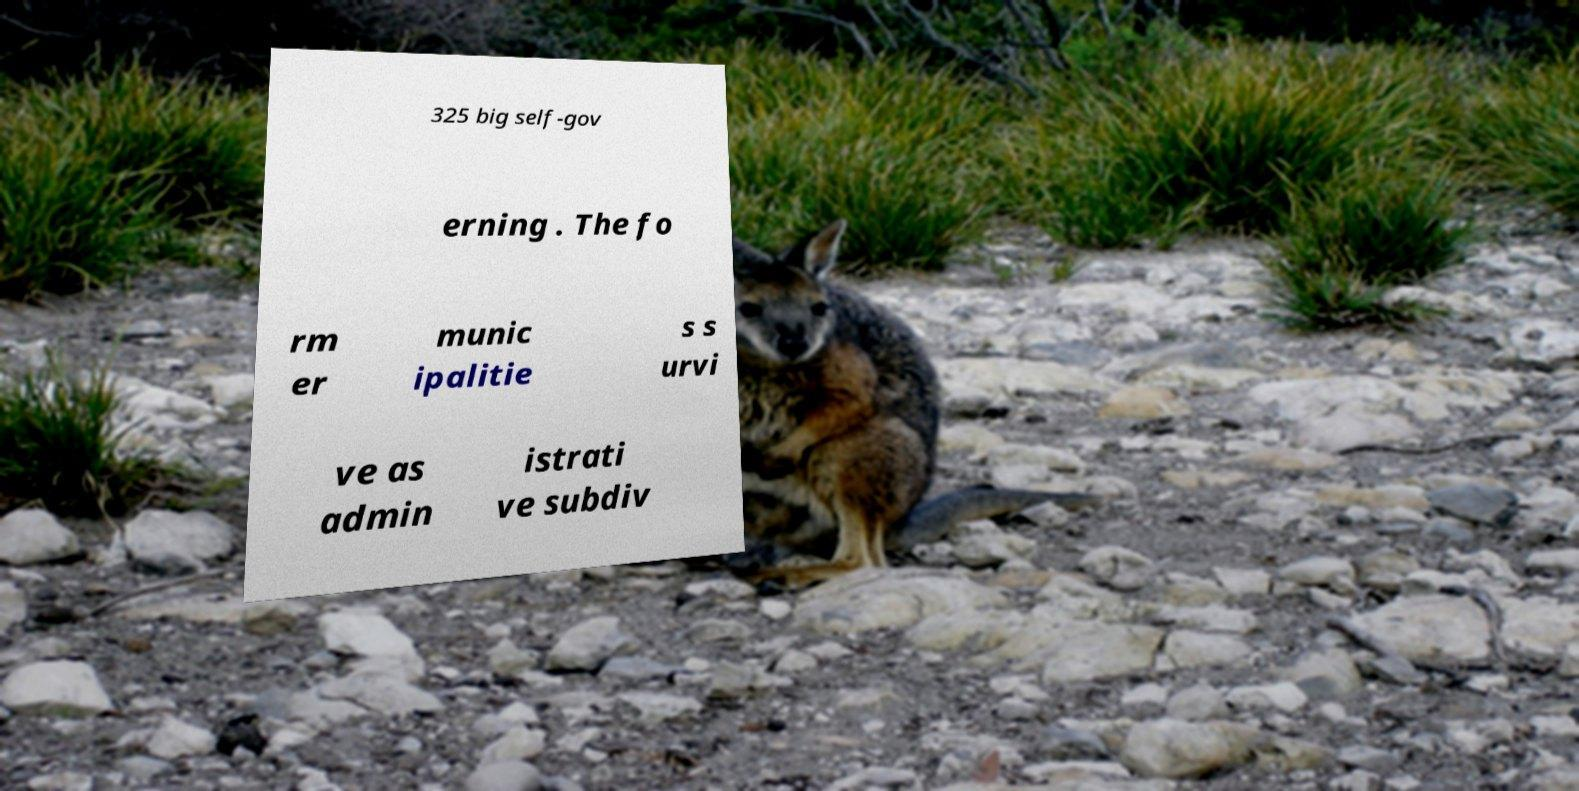I need the written content from this picture converted into text. Can you do that? 325 big self-gov erning . The fo rm er munic ipalitie s s urvi ve as admin istrati ve subdiv 